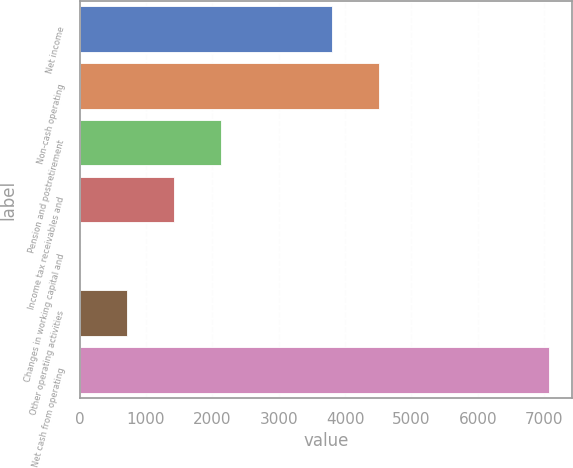Convert chart to OTSL. <chart><loc_0><loc_0><loc_500><loc_500><bar_chart><fcel>Net income<fcel>Non-cash operating<fcel>Pension and postretirement<fcel>Income tax receivables and<fcel>Changes in working capital and<fcel>Other operating activities<fcel>Net cash from operating<nl><fcel>3804<fcel>4510.1<fcel>2130.3<fcel>1424.2<fcel>12<fcel>718.1<fcel>7073<nl></chart> 